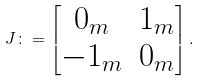Convert formula to latex. <formula><loc_0><loc_0><loc_500><loc_500>J \colon = \begin{bmatrix} 0 _ { m } & 1 _ { m } \\ - 1 _ { m } & 0 _ { m } \end{bmatrix} .</formula> 